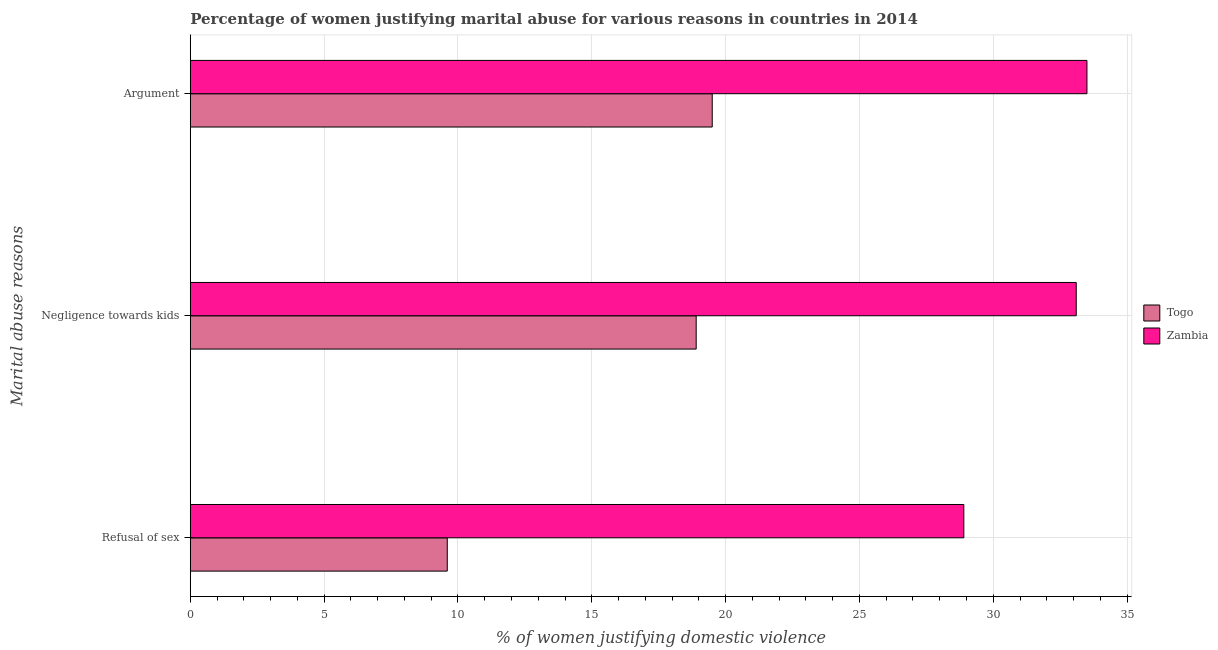How many different coloured bars are there?
Provide a succinct answer. 2. How many bars are there on the 1st tick from the bottom?
Keep it short and to the point. 2. What is the label of the 1st group of bars from the top?
Ensure brevity in your answer.  Argument. What is the percentage of women justifying domestic violence due to negligence towards kids in Togo?
Your answer should be very brief. 18.9. Across all countries, what is the maximum percentage of women justifying domestic violence due to arguments?
Keep it short and to the point. 33.5. In which country was the percentage of women justifying domestic violence due to arguments maximum?
Provide a succinct answer. Zambia. In which country was the percentage of women justifying domestic violence due to negligence towards kids minimum?
Your answer should be compact. Togo. What is the total percentage of women justifying domestic violence due to refusal of sex in the graph?
Your answer should be very brief. 38.5. What is the difference between the percentage of women justifying domestic violence due to arguments in Togo and the percentage of women justifying domestic violence due to refusal of sex in Zambia?
Make the answer very short. -9.4. What is the average percentage of women justifying domestic violence due to refusal of sex per country?
Provide a succinct answer. 19.25. What is the difference between the percentage of women justifying domestic violence due to refusal of sex and percentage of women justifying domestic violence due to negligence towards kids in Zambia?
Provide a short and direct response. -4.2. What is the ratio of the percentage of women justifying domestic violence due to negligence towards kids in Togo to that in Zambia?
Your answer should be compact. 0.57. Is the percentage of women justifying domestic violence due to refusal of sex in Zambia less than that in Togo?
Offer a terse response. No. Is the difference between the percentage of women justifying domestic violence due to negligence towards kids in Zambia and Togo greater than the difference between the percentage of women justifying domestic violence due to arguments in Zambia and Togo?
Your answer should be very brief. Yes. What is the difference between the highest and the second highest percentage of women justifying domestic violence due to arguments?
Keep it short and to the point. 14. What is the difference between the highest and the lowest percentage of women justifying domestic violence due to negligence towards kids?
Ensure brevity in your answer.  14.2. Is the sum of the percentage of women justifying domestic violence due to refusal of sex in Zambia and Togo greater than the maximum percentage of women justifying domestic violence due to negligence towards kids across all countries?
Offer a very short reply. Yes. What does the 2nd bar from the top in Argument represents?
Provide a succinct answer. Togo. What does the 1st bar from the bottom in Refusal of sex represents?
Your answer should be very brief. Togo. How many bars are there?
Your response must be concise. 6. Are all the bars in the graph horizontal?
Your response must be concise. Yes. Does the graph contain grids?
Make the answer very short. Yes. How are the legend labels stacked?
Your answer should be very brief. Vertical. What is the title of the graph?
Offer a terse response. Percentage of women justifying marital abuse for various reasons in countries in 2014. What is the label or title of the X-axis?
Provide a short and direct response. % of women justifying domestic violence. What is the label or title of the Y-axis?
Your answer should be very brief. Marital abuse reasons. What is the % of women justifying domestic violence of Togo in Refusal of sex?
Provide a short and direct response. 9.6. What is the % of women justifying domestic violence in Zambia in Refusal of sex?
Provide a short and direct response. 28.9. What is the % of women justifying domestic violence of Togo in Negligence towards kids?
Offer a terse response. 18.9. What is the % of women justifying domestic violence of Zambia in Negligence towards kids?
Your answer should be very brief. 33.1. What is the % of women justifying domestic violence of Zambia in Argument?
Provide a short and direct response. 33.5. Across all Marital abuse reasons, what is the maximum % of women justifying domestic violence of Zambia?
Keep it short and to the point. 33.5. Across all Marital abuse reasons, what is the minimum % of women justifying domestic violence of Zambia?
Offer a terse response. 28.9. What is the total % of women justifying domestic violence in Zambia in the graph?
Your answer should be compact. 95.5. What is the difference between the % of women justifying domestic violence in Togo in Refusal of sex and that in Negligence towards kids?
Your answer should be very brief. -9.3. What is the difference between the % of women justifying domestic violence in Zambia in Refusal of sex and that in Negligence towards kids?
Provide a short and direct response. -4.2. What is the difference between the % of women justifying domestic violence of Togo in Refusal of sex and that in Argument?
Your response must be concise. -9.9. What is the difference between the % of women justifying domestic violence of Togo in Negligence towards kids and that in Argument?
Provide a short and direct response. -0.6. What is the difference between the % of women justifying domestic violence in Zambia in Negligence towards kids and that in Argument?
Keep it short and to the point. -0.4. What is the difference between the % of women justifying domestic violence of Togo in Refusal of sex and the % of women justifying domestic violence of Zambia in Negligence towards kids?
Your answer should be very brief. -23.5. What is the difference between the % of women justifying domestic violence in Togo in Refusal of sex and the % of women justifying domestic violence in Zambia in Argument?
Offer a terse response. -23.9. What is the difference between the % of women justifying domestic violence in Togo in Negligence towards kids and the % of women justifying domestic violence in Zambia in Argument?
Provide a short and direct response. -14.6. What is the average % of women justifying domestic violence of Zambia per Marital abuse reasons?
Ensure brevity in your answer.  31.83. What is the difference between the % of women justifying domestic violence in Togo and % of women justifying domestic violence in Zambia in Refusal of sex?
Make the answer very short. -19.3. What is the difference between the % of women justifying domestic violence of Togo and % of women justifying domestic violence of Zambia in Negligence towards kids?
Your answer should be very brief. -14.2. What is the difference between the % of women justifying domestic violence in Togo and % of women justifying domestic violence in Zambia in Argument?
Provide a succinct answer. -14. What is the ratio of the % of women justifying domestic violence of Togo in Refusal of sex to that in Negligence towards kids?
Your answer should be very brief. 0.51. What is the ratio of the % of women justifying domestic violence in Zambia in Refusal of sex to that in Negligence towards kids?
Your response must be concise. 0.87. What is the ratio of the % of women justifying domestic violence of Togo in Refusal of sex to that in Argument?
Provide a short and direct response. 0.49. What is the ratio of the % of women justifying domestic violence in Zambia in Refusal of sex to that in Argument?
Give a very brief answer. 0.86. What is the ratio of the % of women justifying domestic violence in Togo in Negligence towards kids to that in Argument?
Make the answer very short. 0.97. What is the difference between the highest and the second highest % of women justifying domestic violence in Togo?
Your answer should be very brief. 0.6. What is the difference between the highest and the lowest % of women justifying domestic violence in Togo?
Provide a succinct answer. 9.9. What is the difference between the highest and the lowest % of women justifying domestic violence in Zambia?
Your response must be concise. 4.6. 